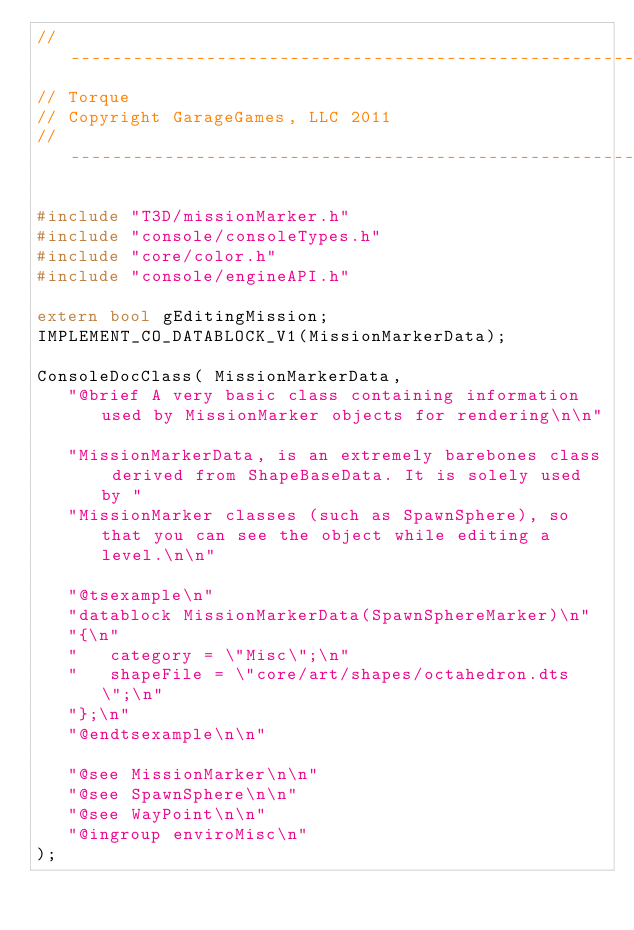<code> <loc_0><loc_0><loc_500><loc_500><_C++_>//-----------------------------------------------------------------------------
// Torque
// Copyright GarageGames, LLC 2011
//-----------------------------------------------------------------------------

#include "T3D/missionMarker.h"
#include "console/consoleTypes.h"
#include "core/color.h"
#include "console/engineAPI.h"

extern bool gEditingMission;
IMPLEMENT_CO_DATABLOCK_V1(MissionMarkerData);

ConsoleDocClass( MissionMarkerData,
   "@brief A very basic class containing information used by MissionMarker objects for rendering\n\n"

   "MissionMarkerData, is an extremely barebones class derived from ShapeBaseData. It is solely used by "
   "MissionMarker classes (such as SpawnSphere), so that you can see the object while editing a level.\n\n"

   "@tsexample\n"
   "datablock MissionMarkerData(SpawnSphereMarker)\n"
   "{\n"
   "   category = \"Misc\";\n"
   "   shapeFile = \"core/art/shapes/octahedron.dts\";\n"
   "};\n"
   "@endtsexample\n\n"

   "@see MissionMarker\n\n"
   "@see SpawnSphere\n\n"
   "@see WayPoint\n\n"
   "@ingroup enviroMisc\n"
);
</code> 